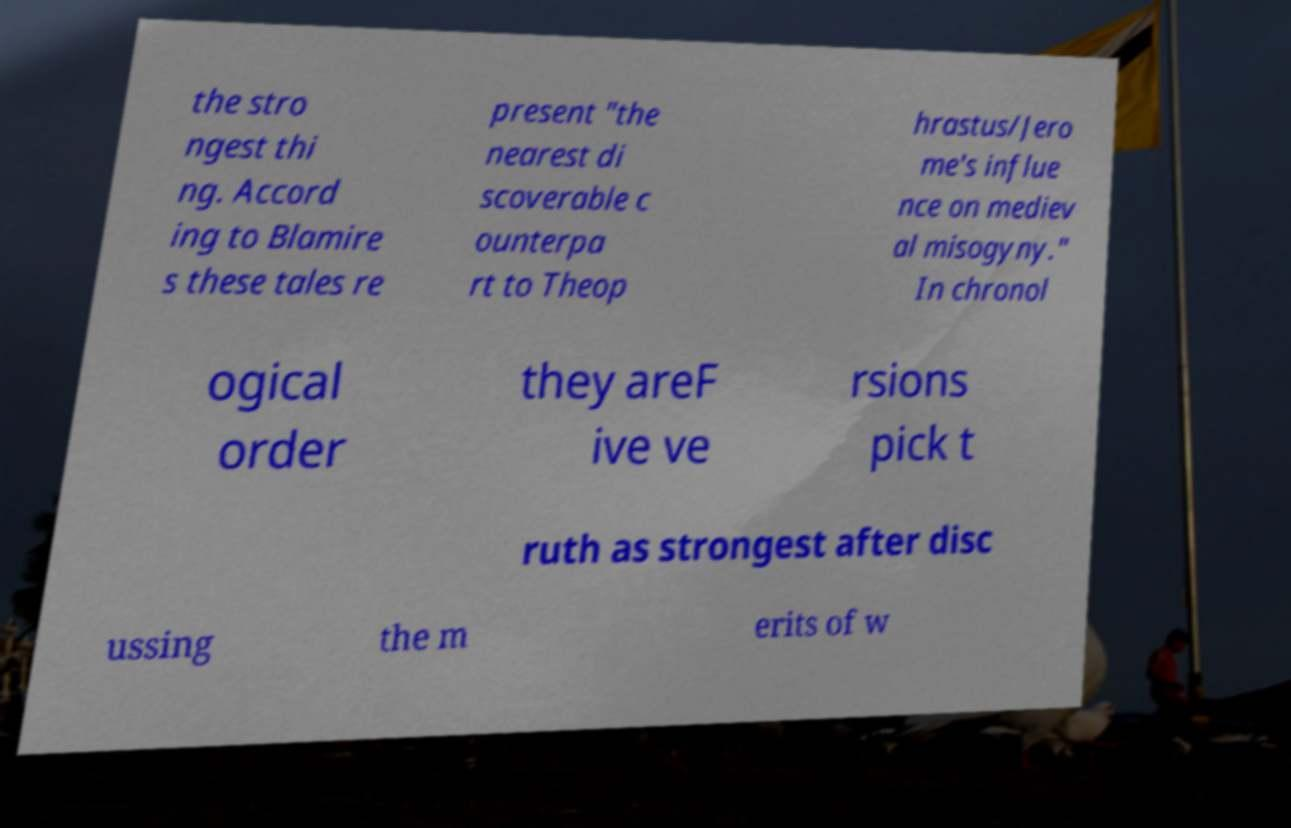I need the written content from this picture converted into text. Can you do that? the stro ngest thi ng. Accord ing to Blamire s these tales re present "the nearest di scoverable c ounterpa rt to Theop hrastus/Jero me's influe nce on mediev al misogyny." In chronol ogical order they areF ive ve rsions pick t ruth as strongest after disc ussing the m erits of w 